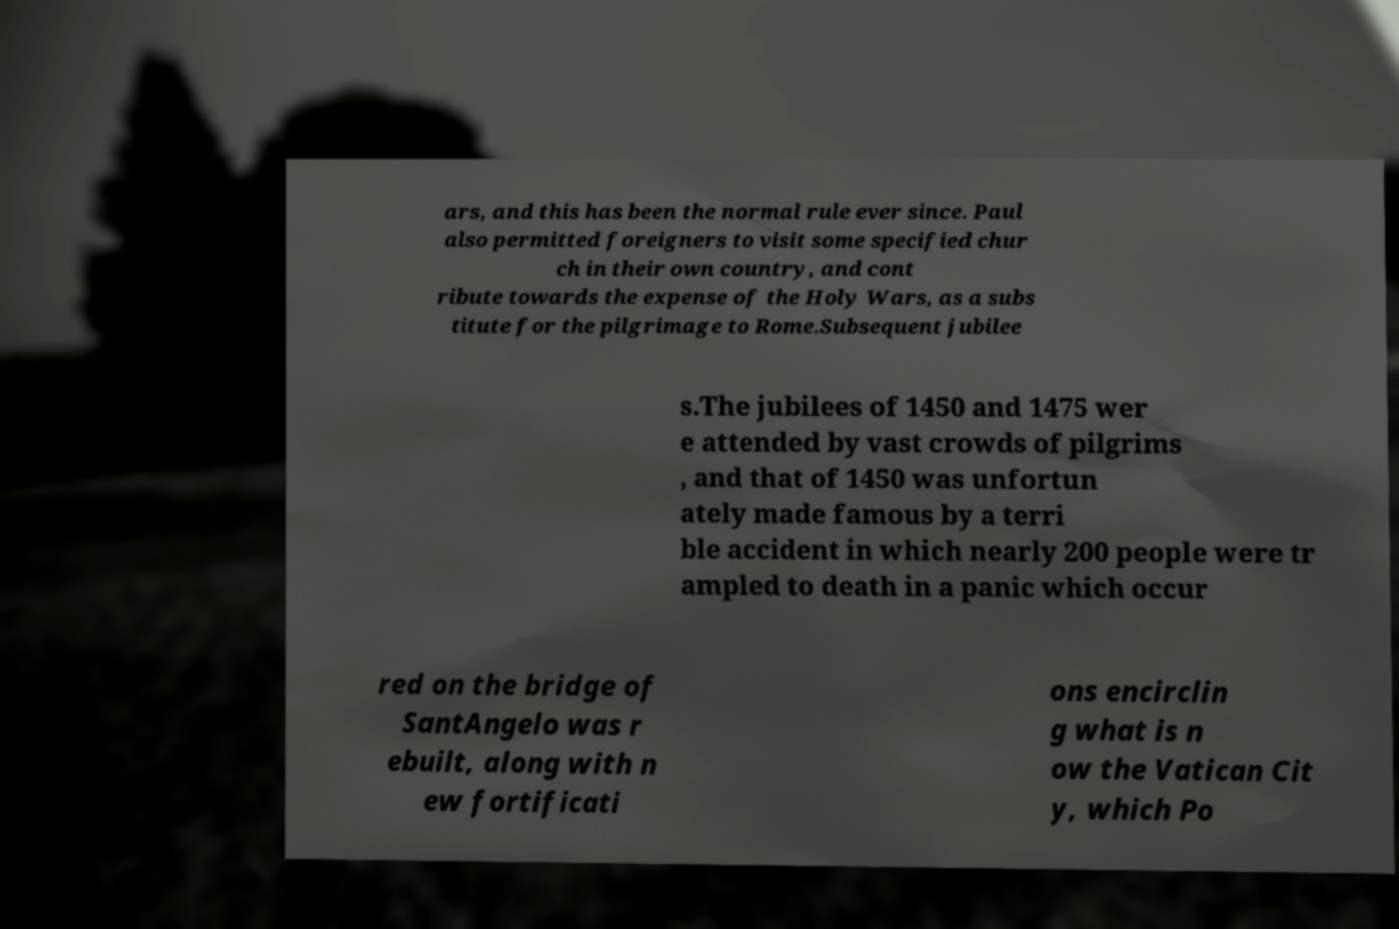Please identify and transcribe the text found in this image. ars, and this has been the normal rule ever since. Paul also permitted foreigners to visit some specified chur ch in their own country, and cont ribute towards the expense of the Holy Wars, as a subs titute for the pilgrimage to Rome.Subsequent jubilee s.The jubilees of 1450 and 1475 wer e attended by vast crowds of pilgrims , and that of 1450 was unfortun ately made famous by a terri ble accident in which nearly 200 people were tr ampled to death in a panic which occur red on the bridge of SantAngelo was r ebuilt, along with n ew fortificati ons encirclin g what is n ow the Vatican Cit y, which Po 